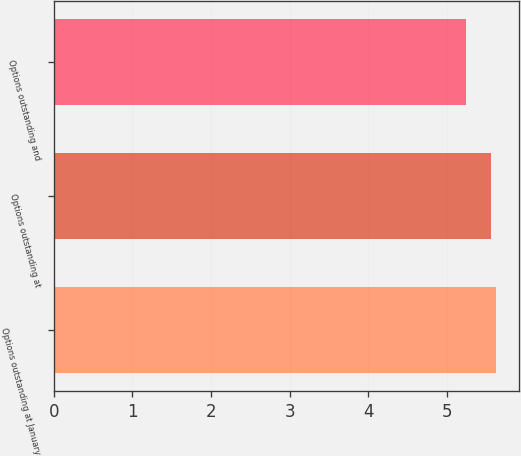Convert chart to OTSL. <chart><loc_0><loc_0><loc_500><loc_500><bar_chart><fcel>Options outstanding at January<fcel>Options outstanding at<fcel>Options outstanding and<nl><fcel>5.63<fcel>5.56<fcel>5.24<nl></chart> 